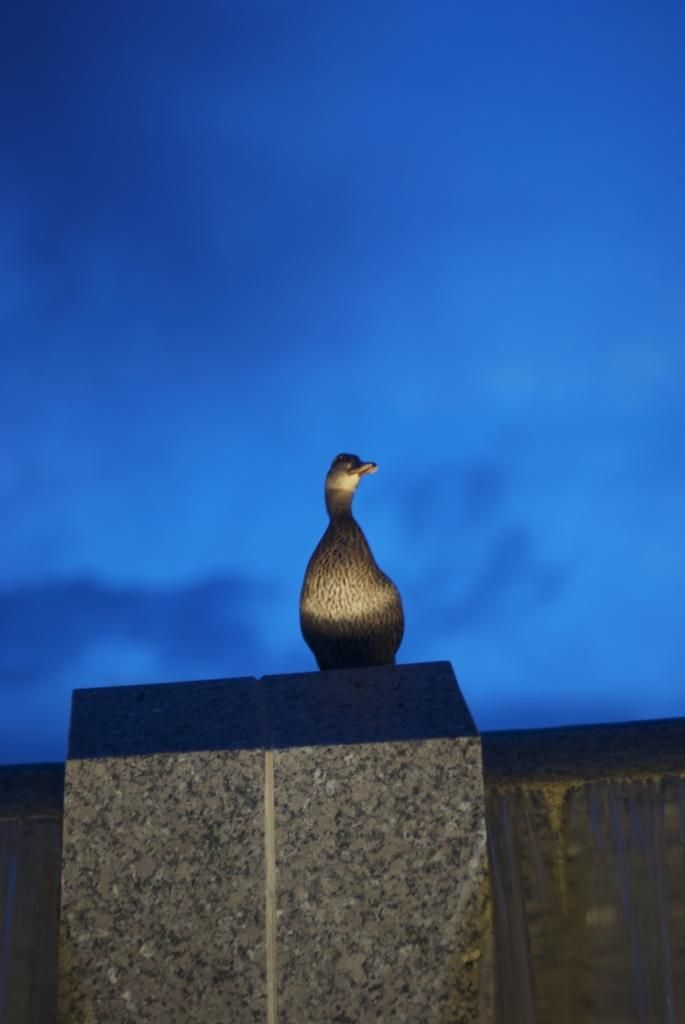What type of animal is in the image? There is a bird in the image. Where is the bird located? The bird is on a pillar. What color is the background of the image? The background of the image is blue. What sound does the bird make in the image? The image does not provide any information about the bird's sound, so it cannot be determined from the image. 